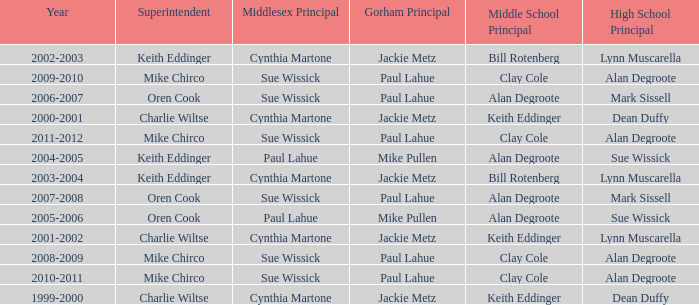How many high school principals were there in 2000-2001? Dean Duffy. 